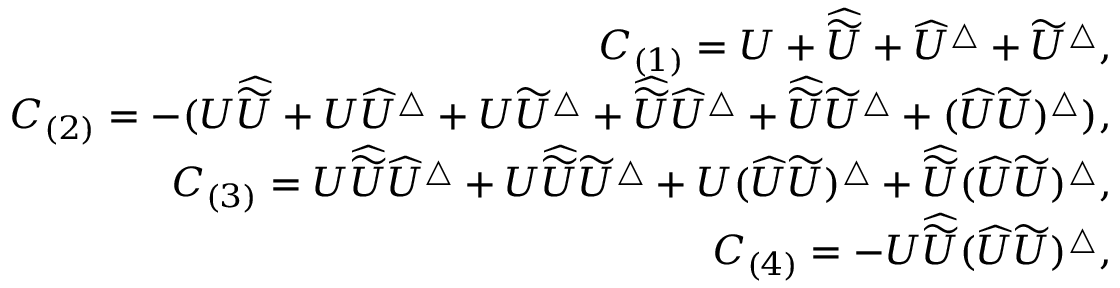<formula> <loc_0><loc_0><loc_500><loc_500>\begin{array} { r l r } & { C _ { ( 1 ) } = U + \widehat { \widetilde { U } } + \widehat { U } ^ { \bigtriangleup } + \widetilde { U } ^ { \bigtriangleup } , } \\ & { C _ { ( 2 ) } = - ( U \widehat { \widetilde { U } } + U \widehat { U } ^ { \bigtriangleup } + U \widetilde { U } ^ { \bigtriangleup } + \widehat { \widetilde { U } } \widehat { U } ^ { \bigtriangleup } + \widehat { \widetilde { U } } \widetilde { U } ^ { \bigtriangleup } + ( \widehat { U } \widetilde { U } ) ^ { \bigtriangleup } ) , } \\ & { C _ { ( 3 ) } = U \widehat { \widetilde { U } } \widehat { U } ^ { \bigtriangleup } + U \widehat { \widetilde { U } } \widetilde { U } ^ { \bigtriangleup } + U ( \widehat { U } \widetilde { U } ) ^ { \bigtriangleup } + \widehat { \widetilde { U } } ( \widehat { U } \widetilde { U } ) ^ { \bigtriangleup } , } \\ & { C _ { ( 4 ) } = - U \widehat { \widetilde { U } } ( \widehat { U } \widetilde { U } ) ^ { \bigtriangleup } , } \end{array}</formula> 